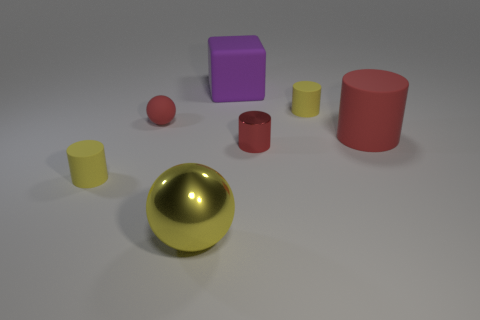Subtract all big rubber cylinders. How many cylinders are left? 3 Add 1 small shiny things. How many objects exist? 8 Subtract all brown cylinders. Subtract all purple spheres. How many cylinders are left? 4 Subtract all cubes. How many objects are left? 6 Add 5 big cylinders. How many big cylinders exist? 6 Subtract 1 red spheres. How many objects are left? 6 Subtract all purple rubber cubes. Subtract all brown metallic objects. How many objects are left? 6 Add 5 yellow metallic spheres. How many yellow metallic spheres are left? 6 